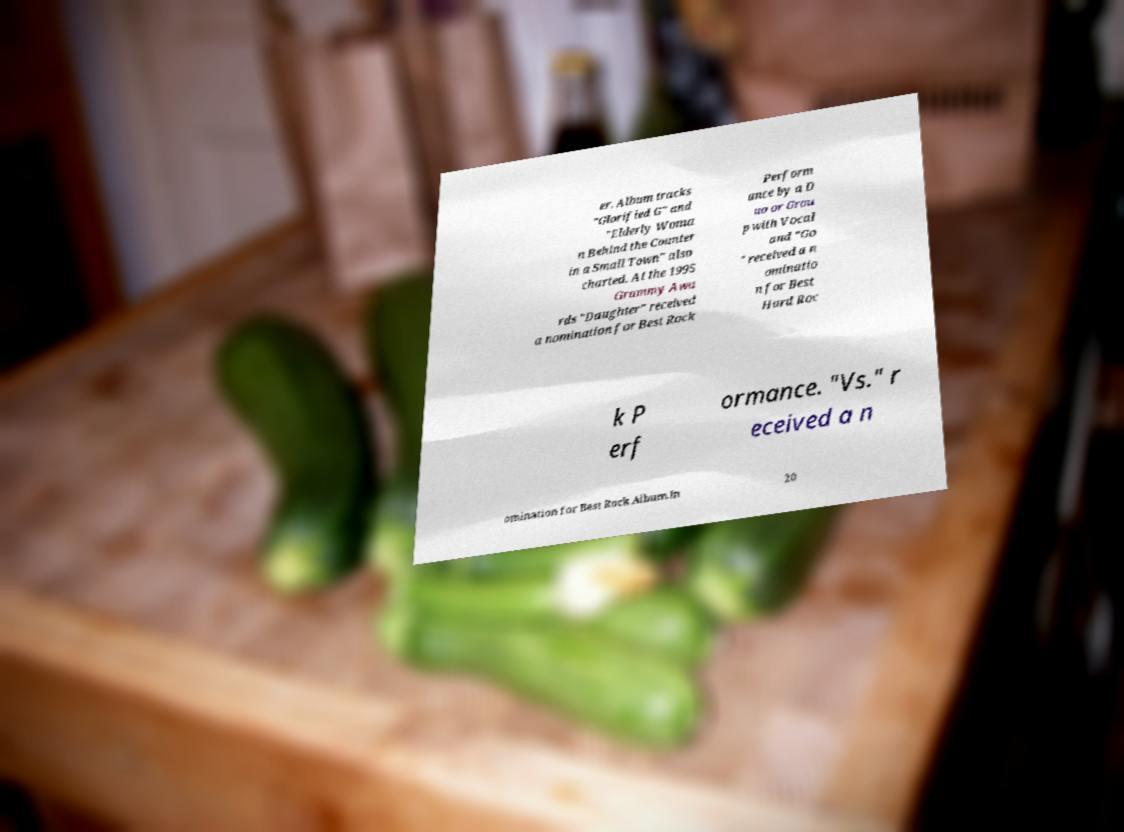Please identify and transcribe the text found in this image. er. Album tracks "Glorified G" and "Elderly Woma n Behind the Counter in a Small Town" also charted. At the 1995 Grammy Awa rds "Daughter" received a nomination for Best Rock Perform ance by a D uo or Grou p with Vocal and "Go " received a n ominatio n for Best Hard Roc k P erf ormance. "Vs." r eceived a n omination for Best Rock Album.In 20 